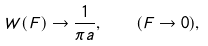<formula> <loc_0><loc_0><loc_500><loc_500>W ( { F } ) \rightarrow \frac { 1 } { \pi a } , \quad ( F \rightarrow 0 ) ,</formula> 